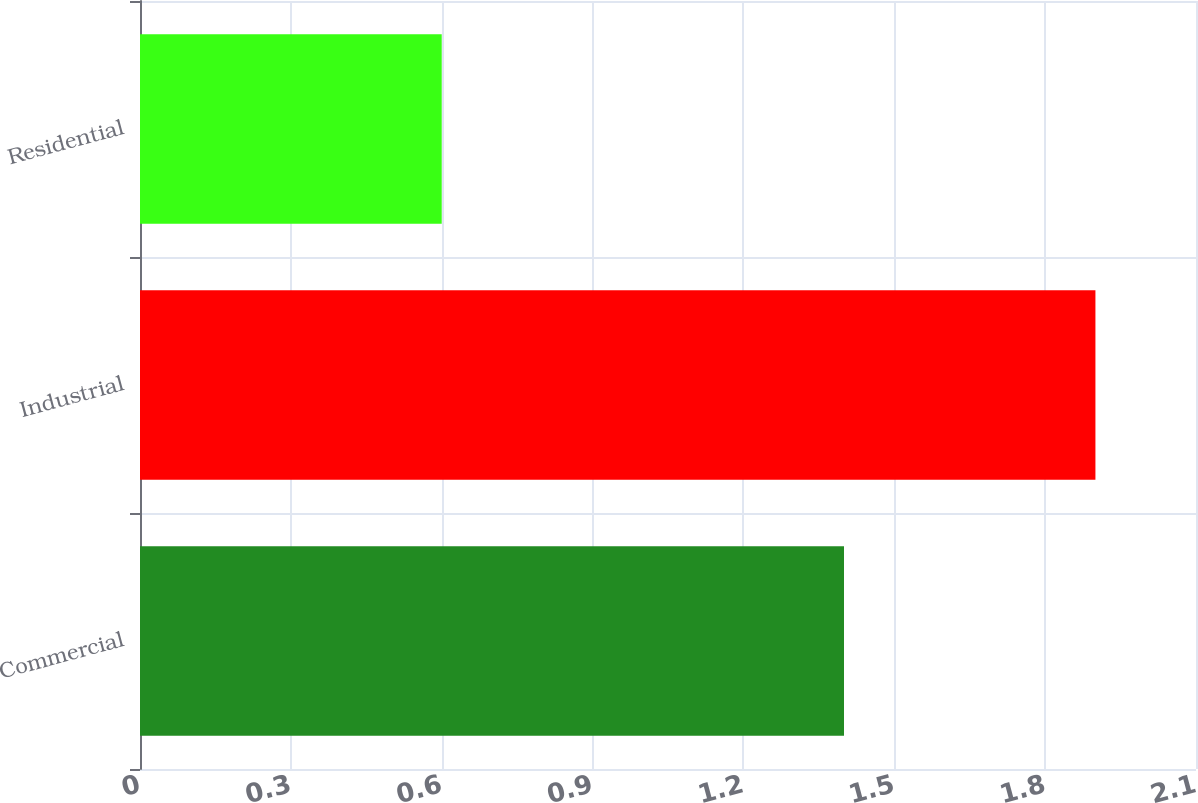<chart> <loc_0><loc_0><loc_500><loc_500><bar_chart><fcel>Commercial<fcel>Industrial<fcel>Residential<nl><fcel>1.4<fcel>1.9<fcel>0.6<nl></chart> 